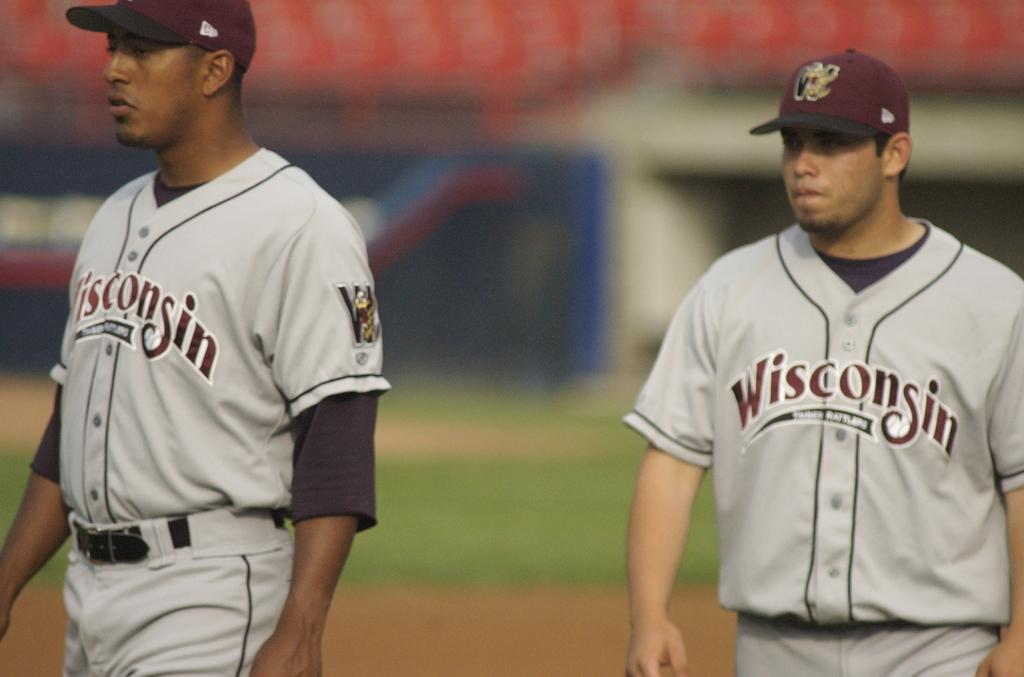<image>
Offer a succinct explanation of the picture presented. Two baseball players from the Wisconsin team wearing gray and maroon uniforms stand closely. 